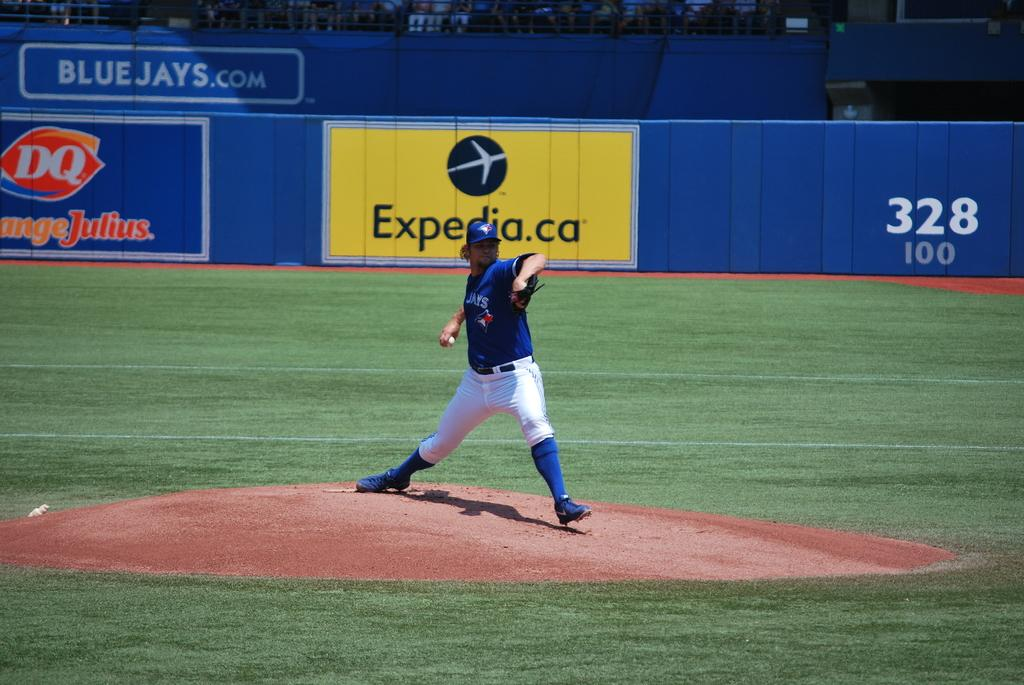<image>
Share a concise interpretation of the image provided. Baseball player getting ready to pitch near an ad for Expedia. 